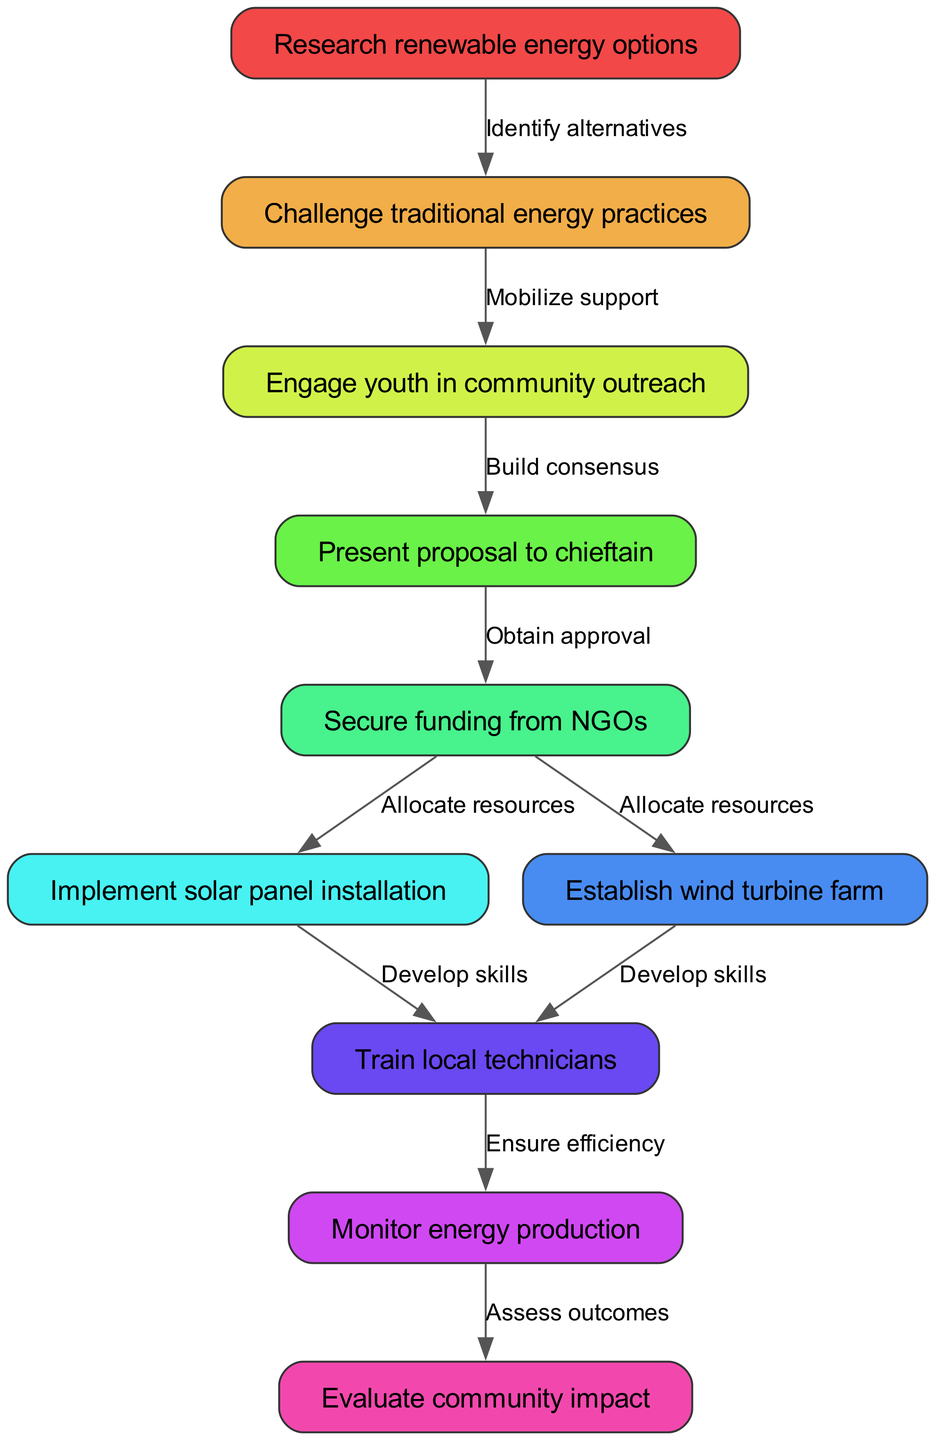What is the first step in the initiative? The first step is to "Research renewable energy options." This is directly indicated at the top of the flowchart as the starting node.
Answer: Research renewable energy options How many nodes are in the diagram? By counting the entries in the "nodes" section of the data, there are 10 distinct steps or stages listed.
Answer: 10 What relationship exists between the nodes "Challenge traditional energy practices" and "Engage youth in community outreach"? The relationship is indicated by an edge that states "Mobilize support," showing that the action of challenging traditional practices leads to youth engagement for support.
Answer: Mobilize support What action is taken after securing funding from NGOs? After securing funding, the next action is to "Implement solar panel installation," which is shown as a subsequent node directly connected by an edge.
Answer: Implement solar panel installation Which processes involve training local technicians? Both the "Implement solar panel installation" and "Establish wind turbine farm" nodes lead to training local technicians, indicating that both actions require developing technical skills.
Answer: Develop skills What is the final evaluation step in the process? The final evaluation step according to the flowchart is "Evaluate community impact," which comes after monitoring energy production.
Answer: Evaluate community impact How many edges connect the nodes in the flowchart? The flowchart includes 9 edges based on the "edges" section, which connects various nodes to represent the flow and relationships between stages.
Answer: 9 Which node is connected to the "Present proposal to chieftain"? This node is directly connected to "Secure funding from NGOs" through the edge that shows it requires obtaining approval following the proposal.
Answer: Secure funding from NGOs What is the purpose of monitoring energy production? The purpose is to "Assess outcomes," which indicates that monitoring helps evaluate the overall effectiveness and impact of the energy initiative.
Answer: Assess outcomes 